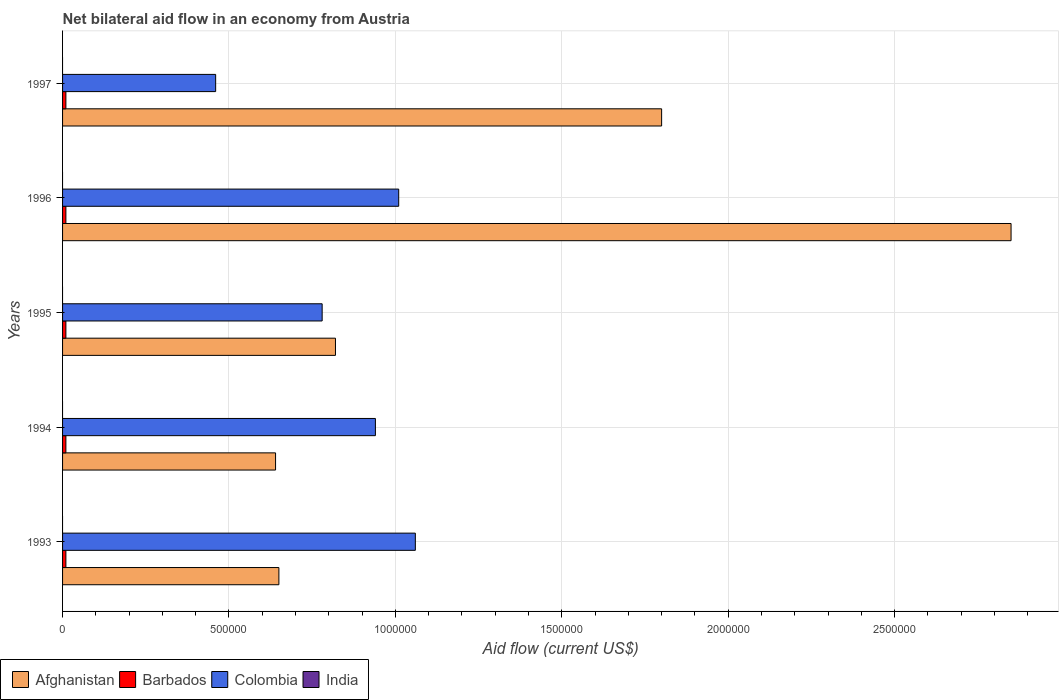How many different coloured bars are there?
Provide a succinct answer. 3. Are the number of bars per tick equal to the number of legend labels?
Provide a short and direct response. No. How many bars are there on the 3rd tick from the bottom?
Ensure brevity in your answer.  3. What is the label of the 1st group of bars from the top?
Offer a terse response. 1997. Across all years, what is the maximum net bilateral aid flow in Colombia?
Ensure brevity in your answer.  1.06e+06. What is the total net bilateral aid flow in India in the graph?
Give a very brief answer. 0. What is the difference between the net bilateral aid flow in Afghanistan in 1993 and that in 1995?
Give a very brief answer. -1.70e+05. What is the difference between the net bilateral aid flow in India in 1994 and the net bilateral aid flow in Barbados in 1996?
Your response must be concise. -10000. What is the average net bilateral aid flow in Afghanistan per year?
Your answer should be compact. 1.35e+06. In the year 1993, what is the difference between the net bilateral aid flow in Colombia and net bilateral aid flow in Afghanistan?
Provide a succinct answer. 4.10e+05. What is the ratio of the net bilateral aid flow in Afghanistan in 1993 to that in 1995?
Offer a terse response. 0.79. What is the difference between the highest and the second highest net bilateral aid flow in Afghanistan?
Provide a succinct answer. 1.05e+06. What is the difference between the highest and the lowest net bilateral aid flow in Afghanistan?
Offer a very short reply. 2.21e+06. In how many years, is the net bilateral aid flow in India greater than the average net bilateral aid flow in India taken over all years?
Offer a terse response. 0. Is the sum of the net bilateral aid flow in Afghanistan in 1996 and 1997 greater than the maximum net bilateral aid flow in India across all years?
Your response must be concise. Yes. Are all the bars in the graph horizontal?
Your answer should be very brief. Yes. What is the difference between two consecutive major ticks on the X-axis?
Your response must be concise. 5.00e+05. Are the values on the major ticks of X-axis written in scientific E-notation?
Your answer should be very brief. No. Does the graph contain any zero values?
Ensure brevity in your answer.  Yes. Where does the legend appear in the graph?
Offer a terse response. Bottom left. How many legend labels are there?
Your answer should be compact. 4. What is the title of the graph?
Your answer should be very brief. Net bilateral aid flow in an economy from Austria. What is the Aid flow (current US$) in Afghanistan in 1993?
Your answer should be very brief. 6.50e+05. What is the Aid flow (current US$) of Barbados in 1993?
Your answer should be compact. 10000. What is the Aid flow (current US$) of Colombia in 1993?
Ensure brevity in your answer.  1.06e+06. What is the Aid flow (current US$) in Afghanistan in 1994?
Make the answer very short. 6.40e+05. What is the Aid flow (current US$) in Barbados in 1994?
Your answer should be compact. 10000. What is the Aid flow (current US$) of Colombia in 1994?
Ensure brevity in your answer.  9.40e+05. What is the Aid flow (current US$) of India in 1994?
Offer a very short reply. 0. What is the Aid flow (current US$) in Afghanistan in 1995?
Your answer should be compact. 8.20e+05. What is the Aid flow (current US$) in Barbados in 1995?
Provide a succinct answer. 10000. What is the Aid flow (current US$) in Colombia in 1995?
Keep it short and to the point. 7.80e+05. What is the Aid flow (current US$) of Afghanistan in 1996?
Make the answer very short. 2.85e+06. What is the Aid flow (current US$) of Colombia in 1996?
Give a very brief answer. 1.01e+06. What is the Aid flow (current US$) of India in 1996?
Provide a short and direct response. 0. What is the Aid flow (current US$) of Afghanistan in 1997?
Provide a succinct answer. 1.80e+06. What is the Aid flow (current US$) in Colombia in 1997?
Ensure brevity in your answer.  4.60e+05. What is the Aid flow (current US$) in India in 1997?
Offer a very short reply. 0. Across all years, what is the maximum Aid flow (current US$) in Afghanistan?
Your answer should be compact. 2.85e+06. Across all years, what is the maximum Aid flow (current US$) in Colombia?
Provide a succinct answer. 1.06e+06. Across all years, what is the minimum Aid flow (current US$) of Afghanistan?
Your answer should be compact. 6.40e+05. Across all years, what is the minimum Aid flow (current US$) in Colombia?
Your answer should be very brief. 4.60e+05. What is the total Aid flow (current US$) in Afghanistan in the graph?
Provide a short and direct response. 6.76e+06. What is the total Aid flow (current US$) in Barbados in the graph?
Your answer should be compact. 5.00e+04. What is the total Aid flow (current US$) in Colombia in the graph?
Provide a short and direct response. 4.25e+06. What is the total Aid flow (current US$) in India in the graph?
Your response must be concise. 0. What is the difference between the Aid flow (current US$) of Afghanistan in 1993 and that in 1994?
Provide a succinct answer. 10000. What is the difference between the Aid flow (current US$) of Colombia in 1993 and that in 1994?
Offer a very short reply. 1.20e+05. What is the difference between the Aid flow (current US$) in Afghanistan in 1993 and that in 1995?
Keep it short and to the point. -1.70e+05. What is the difference between the Aid flow (current US$) in Afghanistan in 1993 and that in 1996?
Make the answer very short. -2.20e+06. What is the difference between the Aid flow (current US$) in Barbados in 1993 and that in 1996?
Provide a succinct answer. 0. What is the difference between the Aid flow (current US$) in Colombia in 1993 and that in 1996?
Keep it short and to the point. 5.00e+04. What is the difference between the Aid flow (current US$) in Afghanistan in 1993 and that in 1997?
Your answer should be very brief. -1.15e+06. What is the difference between the Aid flow (current US$) in Barbados in 1993 and that in 1997?
Make the answer very short. 0. What is the difference between the Aid flow (current US$) of Colombia in 1993 and that in 1997?
Provide a succinct answer. 6.00e+05. What is the difference between the Aid flow (current US$) in Afghanistan in 1994 and that in 1995?
Your answer should be compact. -1.80e+05. What is the difference between the Aid flow (current US$) in Barbados in 1994 and that in 1995?
Give a very brief answer. 0. What is the difference between the Aid flow (current US$) in Afghanistan in 1994 and that in 1996?
Give a very brief answer. -2.21e+06. What is the difference between the Aid flow (current US$) of Colombia in 1994 and that in 1996?
Give a very brief answer. -7.00e+04. What is the difference between the Aid flow (current US$) of Afghanistan in 1994 and that in 1997?
Provide a succinct answer. -1.16e+06. What is the difference between the Aid flow (current US$) in Barbados in 1994 and that in 1997?
Offer a very short reply. 0. What is the difference between the Aid flow (current US$) of Afghanistan in 1995 and that in 1996?
Give a very brief answer. -2.03e+06. What is the difference between the Aid flow (current US$) in Colombia in 1995 and that in 1996?
Offer a terse response. -2.30e+05. What is the difference between the Aid flow (current US$) in Afghanistan in 1995 and that in 1997?
Your answer should be very brief. -9.80e+05. What is the difference between the Aid flow (current US$) of Colombia in 1995 and that in 1997?
Ensure brevity in your answer.  3.20e+05. What is the difference between the Aid flow (current US$) of Afghanistan in 1996 and that in 1997?
Offer a very short reply. 1.05e+06. What is the difference between the Aid flow (current US$) of Afghanistan in 1993 and the Aid flow (current US$) of Barbados in 1994?
Provide a succinct answer. 6.40e+05. What is the difference between the Aid flow (current US$) of Barbados in 1993 and the Aid flow (current US$) of Colombia in 1994?
Offer a very short reply. -9.30e+05. What is the difference between the Aid flow (current US$) in Afghanistan in 1993 and the Aid flow (current US$) in Barbados in 1995?
Ensure brevity in your answer.  6.40e+05. What is the difference between the Aid flow (current US$) of Afghanistan in 1993 and the Aid flow (current US$) of Colombia in 1995?
Your answer should be compact. -1.30e+05. What is the difference between the Aid flow (current US$) in Barbados in 1993 and the Aid flow (current US$) in Colombia in 1995?
Your answer should be very brief. -7.70e+05. What is the difference between the Aid flow (current US$) in Afghanistan in 1993 and the Aid flow (current US$) in Barbados in 1996?
Your answer should be compact. 6.40e+05. What is the difference between the Aid flow (current US$) in Afghanistan in 1993 and the Aid flow (current US$) in Colombia in 1996?
Offer a very short reply. -3.60e+05. What is the difference between the Aid flow (current US$) in Afghanistan in 1993 and the Aid flow (current US$) in Barbados in 1997?
Provide a succinct answer. 6.40e+05. What is the difference between the Aid flow (current US$) in Barbados in 1993 and the Aid flow (current US$) in Colombia in 1997?
Your response must be concise. -4.50e+05. What is the difference between the Aid flow (current US$) of Afghanistan in 1994 and the Aid flow (current US$) of Barbados in 1995?
Your response must be concise. 6.30e+05. What is the difference between the Aid flow (current US$) in Afghanistan in 1994 and the Aid flow (current US$) in Colombia in 1995?
Ensure brevity in your answer.  -1.40e+05. What is the difference between the Aid flow (current US$) in Barbados in 1994 and the Aid flow (current US$) in Colombia in 1995?
Provide a succinct answer. -7.70e+05. What is the difference between the Aid flow (current US$) of Afghanistan in 1994 and the Aid flow (current US$) of Barbados in 1996?
Provide a short and direct response. 6.30e+05. What is the difference between the Aid flow (current US$) in Afghanistan in 1994 and the Aid flow (current US$) in Colombia in 1996?
Your answer should be compact. -3.70e+05. What is the difference between the Aid flow (current US$) of Barbados in 1994 and the Aid flow (current US$) of Colombia in 1996?
Provide a short and direct response. -1.00e+06. What is the difference between the Aid flow (current US$) of Afghanistan in 1994 and the Aid flow (current US$) of Barbados in 1997?
Keep it short and to the point. 6.30e+05. What is the difference between the Aid flow (current US$) of Barbados in 1994 and the Aid flow (current US$) of Colombia in 1997?
Your answer should be very brief. -4.50e+05. What is the difference between the Aid flow (current US$) in Afghanistan in 1995 and the Aid flow (current US$) in Barbados in 1996?
Offer a terse response. 8.10e+05. What is the difference between the Aid flow (current US$) in Afghanistan in 1995 and the Aid flow (current US$) in Colombia in 1996?
Make the answer very short. -1.90e+05. What is the difference between the Aid flow (current US$) in Afghanistan in 1995 and the Aid flow (current US$) in Barbados in 1997?
Offer a very short reply. 8.10e+05. What is the difference between the Aid flow (current US$) of Barbados in 1995 and the Aid flow (current US$) of Colombia in 1997?
Offer a terse response. -4.50e+05. What is the difference between the Aid flow (current US$) in Afghanistan in 1996 and the Aid flow (current US$) in Barbados in 1997?
Keep it short and to the point. 2.84e+06. What is the difference between the Aid flow (current US$) in Afghanistan in 1996 and the Aid flow (current US$) in Colombia in 1997?
Provide a succinct answer. 2.39e+06. What is the difference between the Aid flow (current US$) of Barbados in 1996 and the Aid flow (current US$) of Colombia in 1997?
Make the answer very short. -4.50e+05. What is the average Aid flow (current US$) of Afghanistan per year?
Keep it short and to the point. 1.35e+06. What is the average Aid flow (current US$) in Barbados per year?
Your answer should be compact. 10000. What is the average Aid flow (current US$) in Colombia per year?
Ensure brevity in your answer.  8.50e+05. In the year 1993, what is the difference between the Aid flow (current US$) in Afghanistan and Aid flow (current US$) in Barbados?
Your response must be concise. 6.40e+05. In the year 1993, what is the difference between the Aid flow (current US$) of Afghanistan and Aid flow (current US$) of Colombia?
Offer a very short reply. -4.10e+05. In the year 1993, what is the difference between the Aid flow (current US$) of Barbados and Aid flow (current US$) of Colombia?
Your answer should be very brief. -1.05e+06. In the year 1994, what is the difference between the Aid flow (current US$) in Afghanistan and Aid flow (current US$) in Barbados?
Make the answer very short. 6.30e+05. In the year 1994, what is the difference between the Aid flow (current US$) in Afghanistan and Aid flow (current US$) in Colombia?
Ensure brevity in your answer.  -3.00e+05. In the year 1994, what is the difference between the Aid flow (current US$) in Barbados and Aid flow (current US$) in Colombia?
Your answer should be very brief. -9.30e+05. In the year 1995, what is the difference between the Aid flow (current US$) of Afghanistan and Aid flow (current US$) of Barbados?
Ensure brevity in your answer.  8.10e+05. In the year 1995, what is the difference between the Aid flow (current US$) in Afghanistan and Aid flow (current US$) in Colombia?
Ensure brevity in your answer.  4.00e+04. In the year 1995, what is the difference between the Aid flow (current US$) of Barbados and Aid flow (current US$) of Colombia?
Your answer should be very brief. -7.70e+05. In the year 1996, what is the difference between the Aid flow (current US$) in Afghanistan and Aid flow (current US$) in Barbados?
Provide a succinct answer. 2.84e+06. In the year 1996, what is the difference between the Aid flow (current US$) in Afghanistan and Aid flow (current US$) in Colombia?
Your answer should be very brief. 1.84e+06. In the year 1997, what is the difference between the Aid flow (current US$) of Afghanistan and Aid flow (current US$) of Barbados?
Provide a succinct answer. 1.79e+06. In the year 1997, what is the difference between the Aid flow (current US$) of Afghanistan and Aid flow (current US$) of Colombia?
Make the answer very short. 1.34e+06. In the year 1997, what is the difference between the Aid flow (current US$) in Barbados and Aid flow (current US$) in Colombia?
Offer a very short reply. -4.50e+05. What is the ratio of the Aid flow (current US$) of Afghanistan in 1993 to that in 1994?
Your response must be concise. 1.02. What is the ratio of the Aid flow (current US$) in Barbados in 1993 to that in 1994?
Ensure brevity in your answer.  1. What is the ratio of the Aid flow (current US$) in Colombia in 1993 to that in 1994?
Keep it short and to the point. 1.13. What is the ratio of the Aid flow (current US$) in Afghanistan in 1993 to that in 1995?
Keep it short and to the point. 0.79. What is the ratio of the Aid flow (current US$) of Colombia in 1993 to that in 1995?
Ensure brevity in your answer.  1.36. What is the ratio of the Aid flow (current US$) of Afghanistan in 1993 to that in 1996?
Make the answer very short. 0.23. What is the ratio of the Aid flow (current US$) of Barbados in 1993 to that in 1996?
Provide a short and direct response. 1. What is the ratio of the Aid flow (current US$) in Colombia in 1993 to that in 1996?
Your answer should be compact. 1.05. What is the ratio of the Aid flow (current US$) of Afghanistan in 1993 to that in 1997?
Offer a very short reply. 0.36. What is the ratio of the Aid flow (current US$) of Colombia in 1993 to that in 1997?
Your response must be concise. 2.3. What is the ratio of the Aid flow (current US$) in Afghanistan in 1994 to that in 1995?
Your answer should be very brief. 0.78. What is the ratio of the Aid flow (current US$) of Colombia in 1994 to that in 1995?
Offer a terse response. 1.21. What is the ratio of the Aid flow (current US$) in Afghanistan in 1994 to that in 1996?
Make the answer very short. 0.22. What is the ratio of the Aid flow (current US$) in Barbados in 1994 to that in 1996?
Offer a terse response. 1. What is the ratio of the Aid flow (current US$) in Colombia in 1994 to that in 1996?
Ensure brevity in your answer.  0.93. What is the ratio of the Aid flow (current US$) in Afghanistan in 1994 to that in 1997?
Keep it short and to the point. 0.36. What is the ratio of the Aid flow (current US$) in Colombia in 1994 to that in 1997?
Provide a succinct answer. 2.04. What is the ratio of the Aid flow (current US$) of Afghanistan in 1995 to that in 1996?
Ensure brevity in your answer.  0.29. What is the ratio of the Aid flow (current US$) of Barbados in 1995 to that in 1996?
Keep it short and to the point. 1. What is the ratio of the Aid flow (current US$) of Colombia in 1995 to that in 1996?
Your answer should be very brief. 0.77. What is the ratio of the Aid flow (current US$) in Afghanistan in 1995 to that in 1997?
Provide a short and direct response. 0.46. What is the ratio of the Aid flow (current US$) of Barbados in 1995 to that in 1997?
Provide a succinct answer. 1. What is the ratio of the Aid flow (current US$) of Colombia in 1995 to that in 1997?
Offer a terse response. 1.7. What is the ratio of the Aid flow (current US$) of Afghanistan in 1996 to that in 1997?
Your response must be concise. 1.58. What is the ratio of the Aid flow (current US$) in Barbados in 1996 to that in 1997?
Your response must be concise. 1. What is the ratio of the Aid flow (current US$) of Colombia in 1996 to that in 1997?
Offer a terse response. 2.2. What is the difference between the highest and the second highest Aid flow (current US$) in Afghanistan?
Ensure brevity in your answer.  1.05e+06. What is the difference between the highest and the second highest Aid flow (current US$) in Colombia?
Provide a short and direct response. 5.00e+04. What is the difference between the highest and the lowest Aid flow (current US$) of Afghanistan?
Keep it short and to the point. 2.21e+06. 